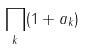<formula> <loc_0><loc_0><loc_500><loc_500>\prod _ { k } ( 1 + a _ { k } )</formula> 